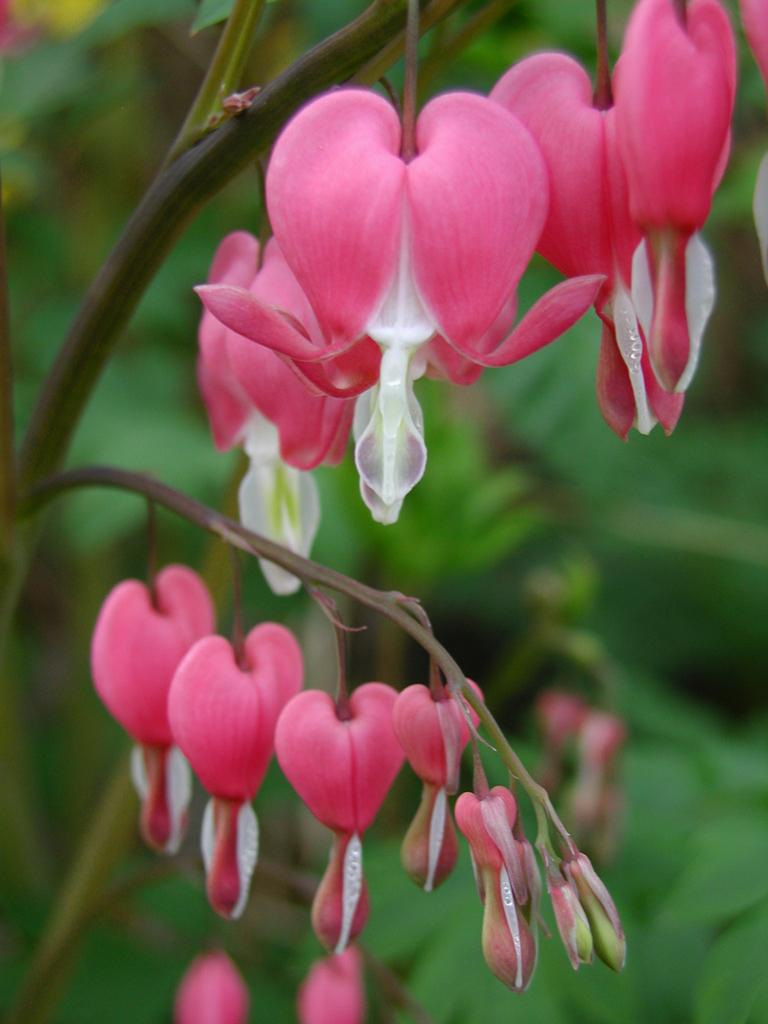What is the main subject of the image? The main subject of the image is a tree stem. What additional features can be observed on the tree? The tree has flowers. What color are the flowers? The flowers are pink in color. What can be seen in the background of the image? There is a green background in the image. Who is the owner of the tree in the image? There is no information about the owner of the tree in the image. What caused the flowers to bloom in the image? There is no information about the cause of the flowers blooming in the image. 